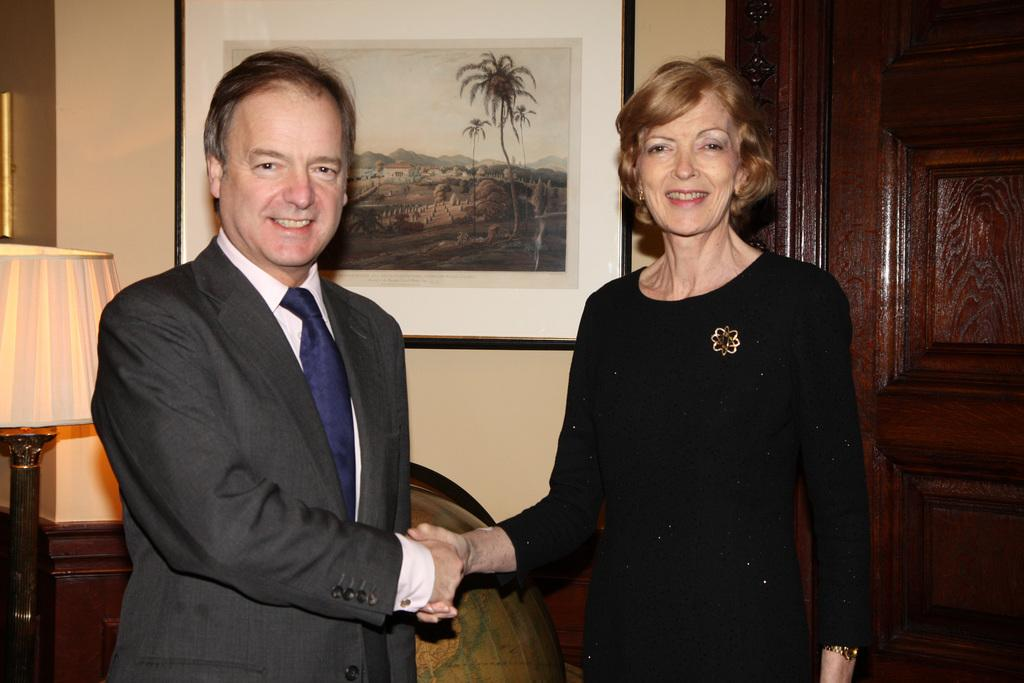Who is present in the image? There is a woman and a man in the image. What are the woman and the man doing? The woman and the man are shaking hands and smiling. What can be seen on the wall in the background? There is a photo frame on the wall in the background. What other objects are visible in the background? There is a chair, a table lamp, and an object in the background. What type of door is visible in the background? There is a wooden door in the background. What type of truck can be seen in the image? There is no truck present in the image. 